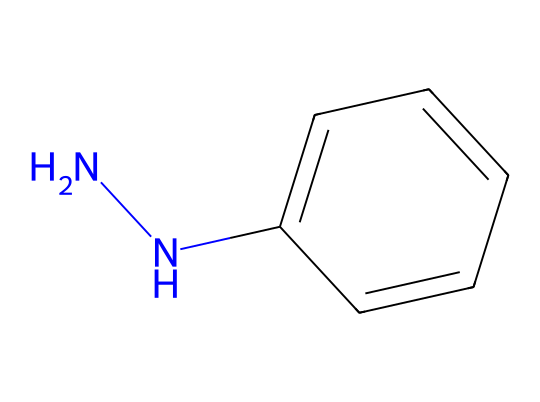What is the chemical name of the compound represented by this SMILES? The SMILES representation includes "NN" indicating the presence of a hydrazine functional group and "c1ccccc1" indicates a phenyl group. Therefore, this compound is recognized as phenylhydrazine.
Answer: phenylhydrazine How many nitrogen atoms are present in the molecule? By examining the SMILES, "NN" indicates two nitrogen atoms are present in the molecule.
Answer: two What type of bonds connect the nitrogen to the carbon atoms in this chemical? In the SMILES structure, nitrogen atoms (N) are connected to a phenyl ring (c1ccccc1) through single bonds, indicative of typical hydrazine linkage.
Answer: single bonds How many aromatic carbon atoms are there in this compound? The phenyl ring consists of six carbon atoms arranged in a cyclic structure, which are all aromatic.
Answer: six What is the primary functional group found in phenylhydrazine? The presence of the "NN" moiety in the SMILES indicates that the primary functional group is a hydrazine group.
Answer: hydrazine What property makes phenylhydrazine useful in urban pest control? Phenylhydrazine's ability to act as a pesticide is attributed to its biological activity, which effectively targets specific pests.
Answer: biological activity Is phenylhydrazine considered hazardous? Due to its reactive nature and potential toxicity, phenylhydrazine is classified as a hazardous chemical.
Answer: hazardous 